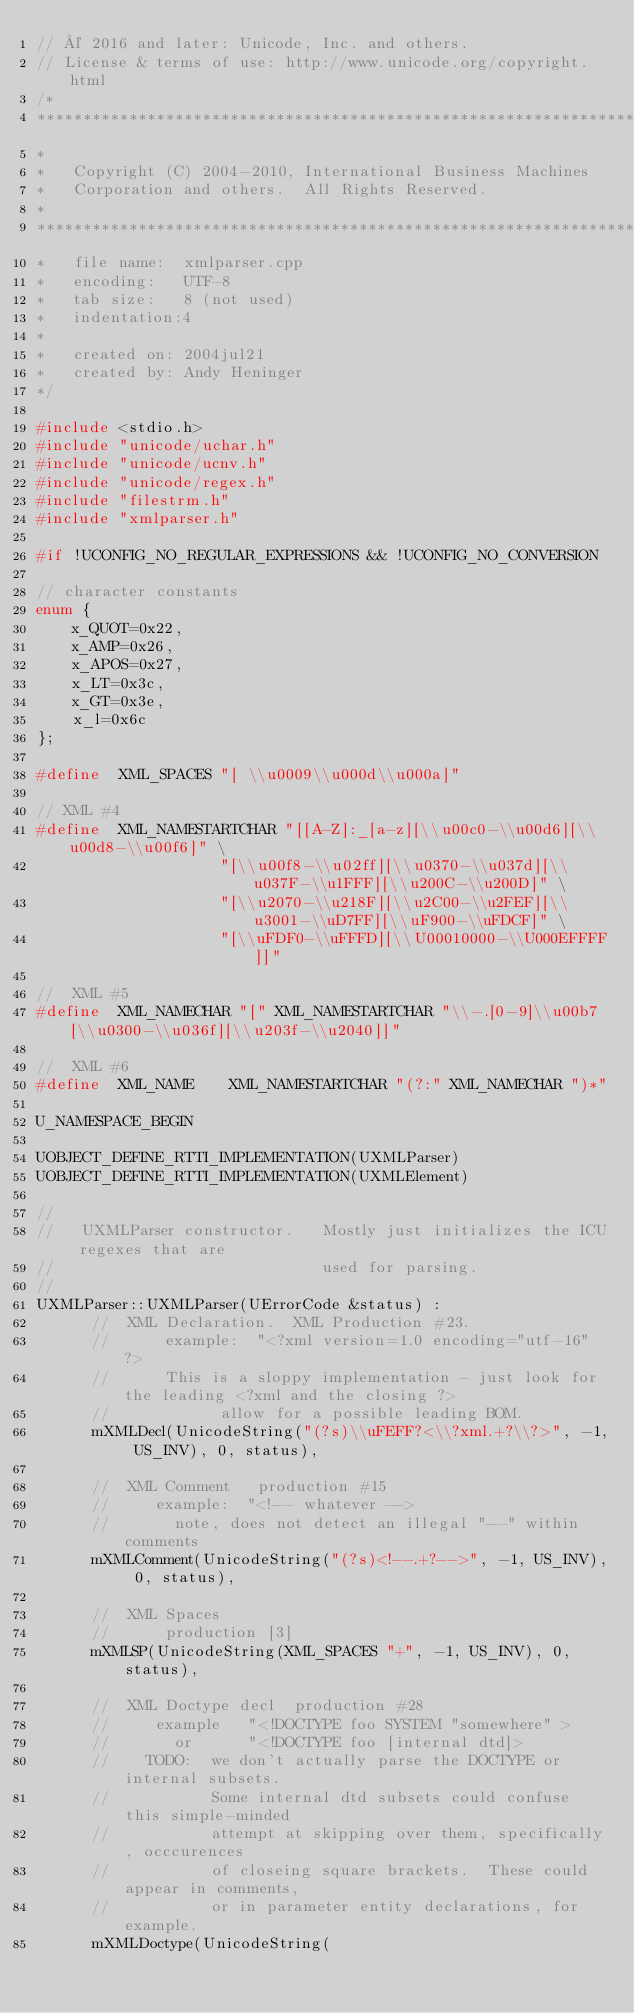Convert code to text. <code><loc_0><loc_0><loc_500><loc_500><_C++_>// © 2016 and later: Unicode, Inc. and others.
// License & terms of use: http://www.unicode.org/copyright.html
/*
*******************************************************************************
*
*   Copyright (C) 2004-2010, International Business Machines
*   Corporation and others.  All Rights Reserved.
*
*******************************************************************************
*   file name:  xmlparser.cpp
*   encoding:   UTF-8
*   tab size:   8 (not used)
*   indentation:4
*
*   created on: 2004jul21
*   created by: Andy Heninger
*/

#include <stdio.h>
#include "unicode/uchar.h"
#include "unicode/ucnv.h"
#include "unicode/regex.h"
#include "filestrm.h"
#include "xmlparser.h"

#if !UCONFIG_NO_REGULAR_EXPRESSIONS && !UCONFIG_NO_CONVERSION

// character constants
enum {
    x_QUOT=0x22,
    x_AMP=0x26,
    x_APOS=0x27,
    x_LT=0x3c,
    x_GT=0x3e,
    x_l=0x6c
};

#define  XML_SPACES "[ \\u0009\\u000d\\u000a]"

// XML #4
#define  XML_NAMESTARTCHAR "[[A-Z]:_[a-z][\\u00c0-\\u00d6][\\u00d8-\\u00f6]" \
                    "[\\u00f8-\\u02ff][\\u0370-\\u037d][\\u037F-\\u1FFF][\\u200C-\\u200D]" \
                    "[\\u2070-\\u218F][\\u2C00-\\u2FEF][\\u3001-\\uD7FF][\\uF900-\\uFDCF]" \
                    "[\\uFDF0-\\uFFFD][\\U00010000-\\U000EFFFF]]"

//  XML #5
#define  XML_NAMECHAR "[" XML_NAMESTARTCHAR "\\-.[0-9]\\u00b7[\\u0300-\\u036f][\\u203f-\\u2040]]"

//  XML #6
#define  XML_NAME    XML_NAMESTARTCHAR "(?:" XML_NAMECHAR ")*"

U_NAMESPACE_BEGIN

UOBJECT_DEFINE_RTTI_IMPLEMENTATION(UXMLParser)
UOBJECT_DEFINE_RTTI_IMPLEMENTATION(UXMLElement)

//
//   UXMLParser constructor.   Mostly just initializes the ICU regexes that are
//                             used for parsing.
//
UXMLParser::UXMLParser(UErrorCode &status) :
      //  XML Declaration.  XML Production #23.
      //      example:  "<?xml version=1.0 encoding="utf-16" ?>
      //      This is a sloppy implementation - just look for the leading <?xml and the closing ?>
      //            allow for a possible leading BOM.
      mXMLDecl(UnicodeString("(?s)\\uFEFF?<\\?xml.+?\\?>", -1, US_INV), 0, status),
      
      //  XML Comment   production #15
      //     example:  "<!-- whatever -->
      //       note, does not detect an illegal "--" within comments
      mXMLComment(UnicodeString("(?s)<!--.+?-->", -1, US_INV), 0, status),
      
      //  XML Spaces
      //      production [3]
      mXMLSP(UnicodeString(XML_SPACES "+", -1, US_INV), 0, status),
      
      //  XML Doctype decl  production #28
      //     example   "<!DOCTYPE foo SYSTEM "somewhere" >
      //       or      "<!DOCTYPE foo [internal dtd]>
      //    TODO:  we don't actually parse the DOCTYPE or internal subsets.
      //           Some internal dtd subsets could confuse this simple-minded
      //           attempt at skipping over them, specifically, occcurences
      //           of closeing square brackets.  These could appear in comments, 
      //           or in parameter entity declarations, for example.
      mXMLDoctype(UnicodeString(</code> 